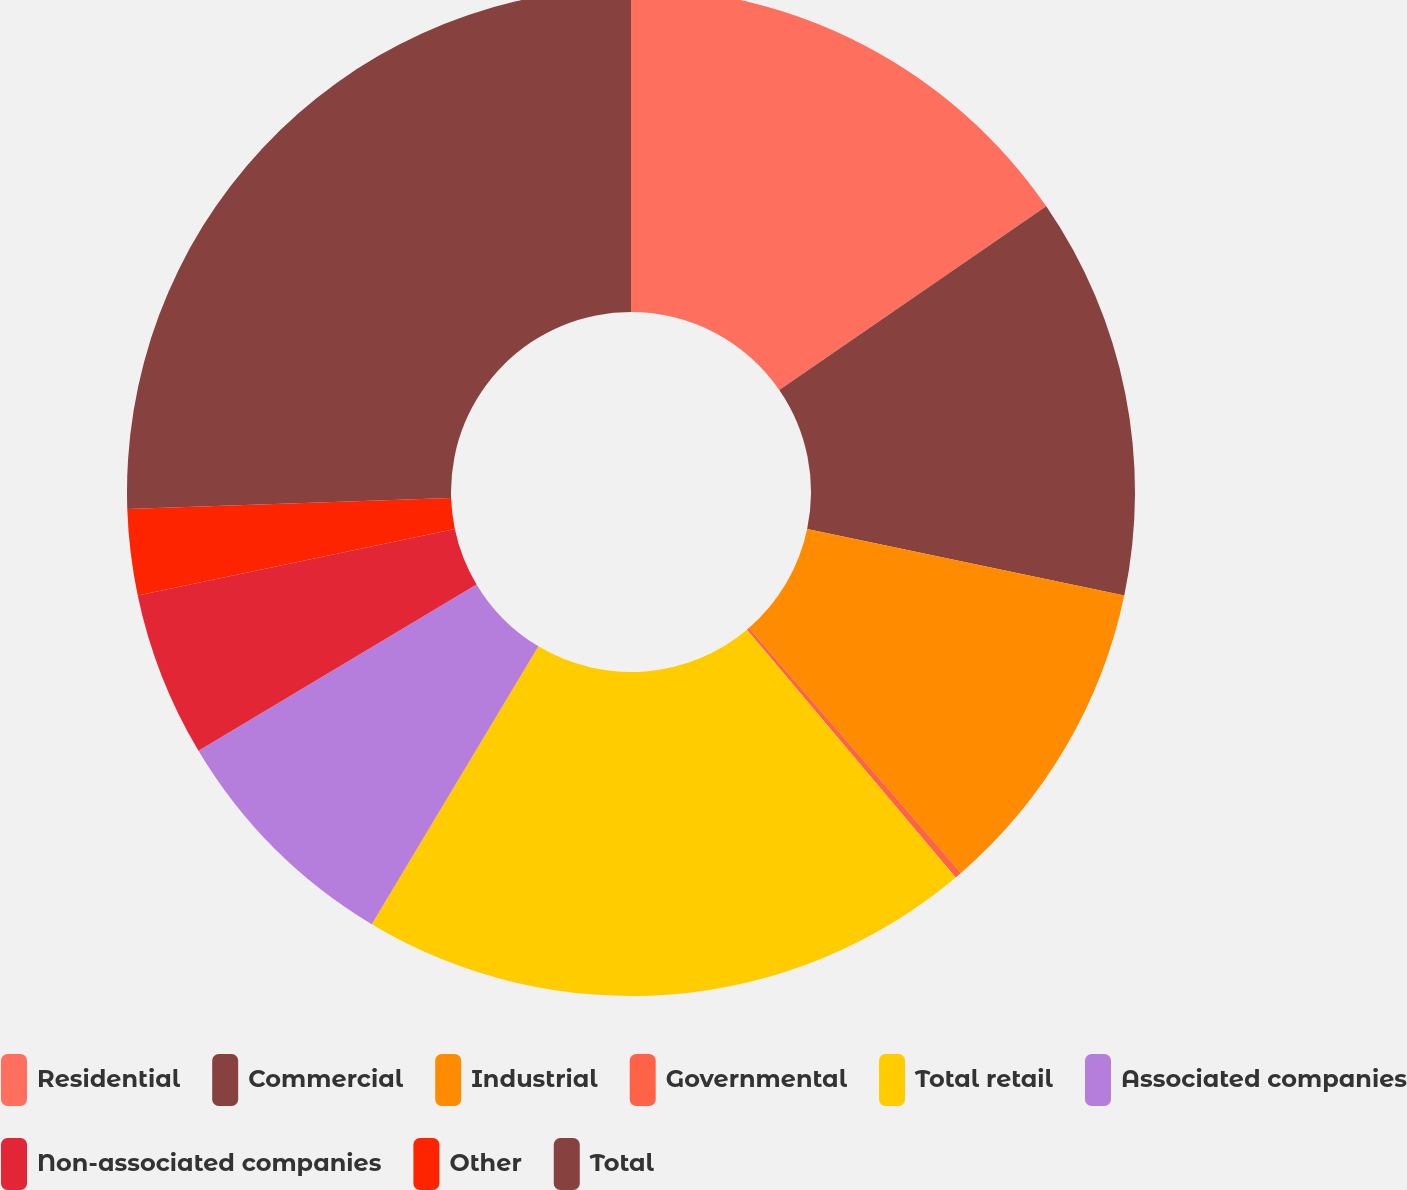Convert chart to OTSL. <chart><loc_0><loc_0><loc_500><loc_500><pie_chart><fcel>Residential<fcel>Commercial<fcel>Industrial<fcel>Governmental<fcel>Total retail<fcel>Associated companies<fcel>Non-associated companies<fcel>Other<fcel>Total<nl><fcel>15.41%<fcel>12.88%<fcel>10.35%<fcel>0.22%<fcel>19.74%<fcel>7.82%<fcel>5.29%<fcel>2.75%<fcel>25.54%<nl></chart> 